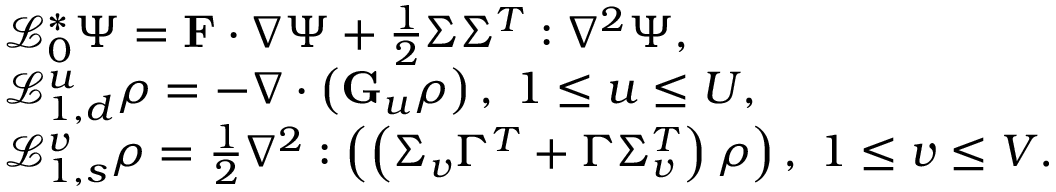<formula> <loc_0><loc_0><loc_500><loc_500>\begin{array} { r l } & { \mathcal { L } _ { 0 } ^ { \ast } \Psi = F \cdot \nabla \Psi + \frac { 1 } { 2 } \Sigma \Sigma ^ { T } \colon \nabla ^ { 2 } \Psi , } \\ & { \mathcal { L } _ { 1 , d } ^ { u } \rho = - \nabla \cdot \left ( G _ { u } \rho \right ) , \, 1 \leq u \leq U , } \\ & { \mathcal { L } _ { 1 , s } ^ { v } \rho = \frac { 1 } { 2 } \nabla ^ { 2 } \colon \left ( \left ( \Sigma _ { v } \Gamma ^ { T } + \Gamma \Sigma _ { v } ^ { T } \right ) \rho \right ) , \, 1 \leq v \leq V . } \end{array}</formula> 